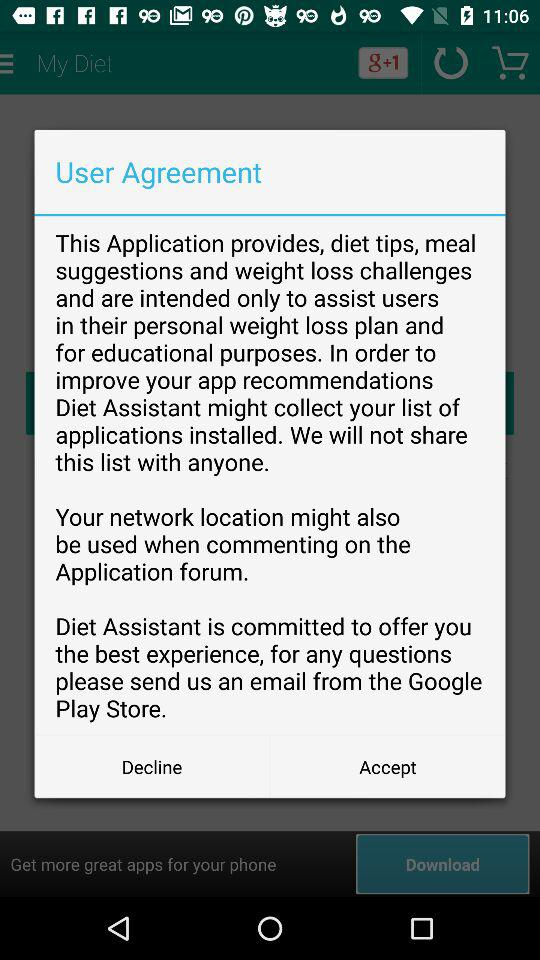What is the name of the application? The name of the application is "Diet Assistant". 